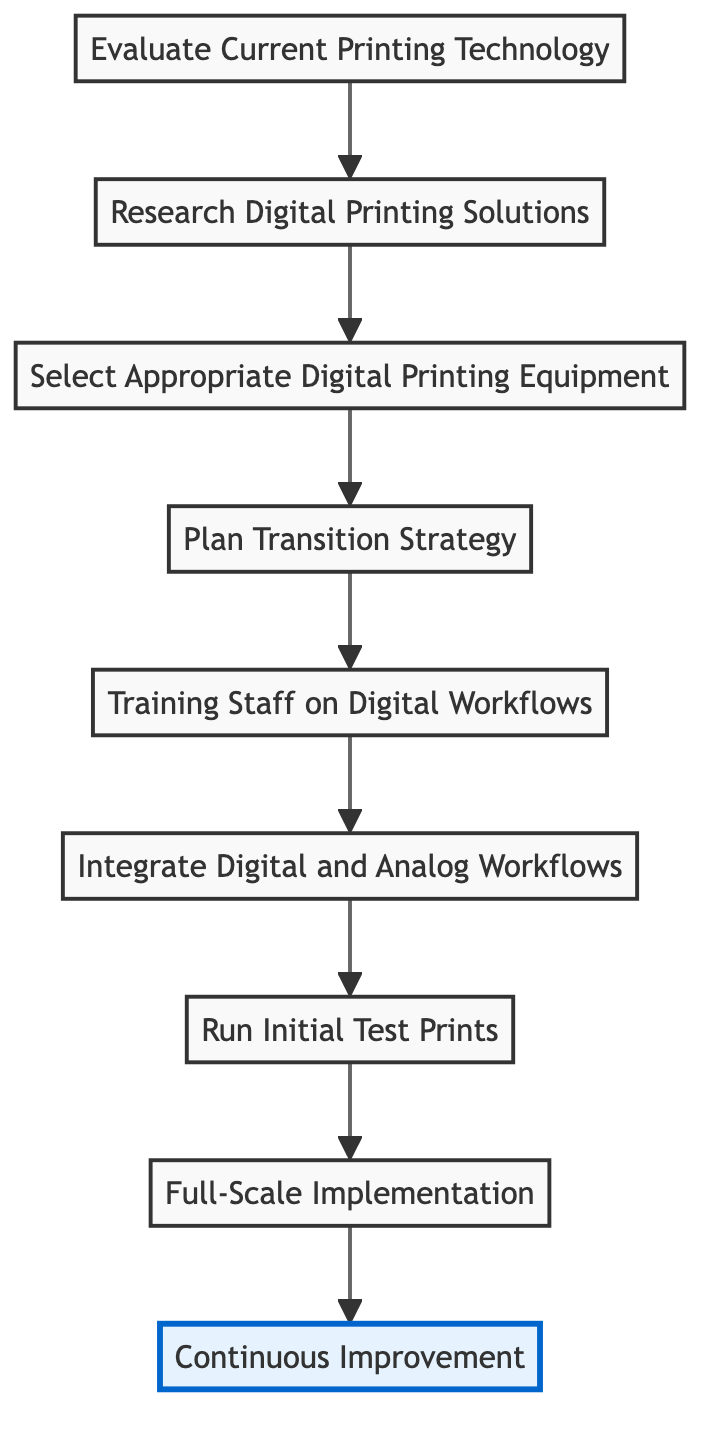What is the first step in the transition? The first step in the transition is identified as "Evaluate Current Printing Technology", which is represented at the bottom of the flowchart.
Answer: Evaluate Current Printing Technology How many total steps are involved in the transition process? By counting the nodes in the flowchart, there are a total of nine steps involved in the transition process.
Answer: 9 What step comes after "Select Appropriate Digital Printing Equipment"? After "Select Appropriate Digital Printing Equipment," the next step in the flowchart is "Plan Transition Strategy," as indicated by the arrow connecting these two nodes.
Answer: Plan Transition Strategy What is the last step in the process? The last step in the transition process is "Continuous Improvement," which is the final node at the top of the flowchart.
Answer: Continuous Improvement Describe the relationship between "Training Staff on Digital Workflows" and "Integrate Digital and Analog Workflows." "Training Staff on Digital Workflows" is a predecessor to "Integrate Digital and Analog Workflows," meaning it must be completed before integration can occur, as indicated by their sequential flow.
Answer: Predecessor relationship How many steps must be completed before "Full-Scale Implementation"? In the flowchart, five steps must be completed before reaching "Full-Scale Implementation," specifically the steps leading up to that point.
Answer: 5 steps Which step involves verifying print quality? The step that involves verifying print quality is "Run Initial Test Prints," which is focused on conducting initial tests and calibrating the digital printers.
Answer: Run Initial Test Prints What is the primary goal of the "Plan Transition Strategy"? The primary goal of the "Plan Transition Strategy" is to develop a detailed strategy for transitioning, including timelines and resource allocation, as described in the node details.
Answer: Develop a detailed strategy What does the flowchart indicate should happen after "Run Initial Test Prints"? After "Run Initial Test Prints," the flowchart indicates that the next action is "Full-Scale Implementation," indicating progress toward larger-scale operations.
Answer: Full-Scale Implementation 